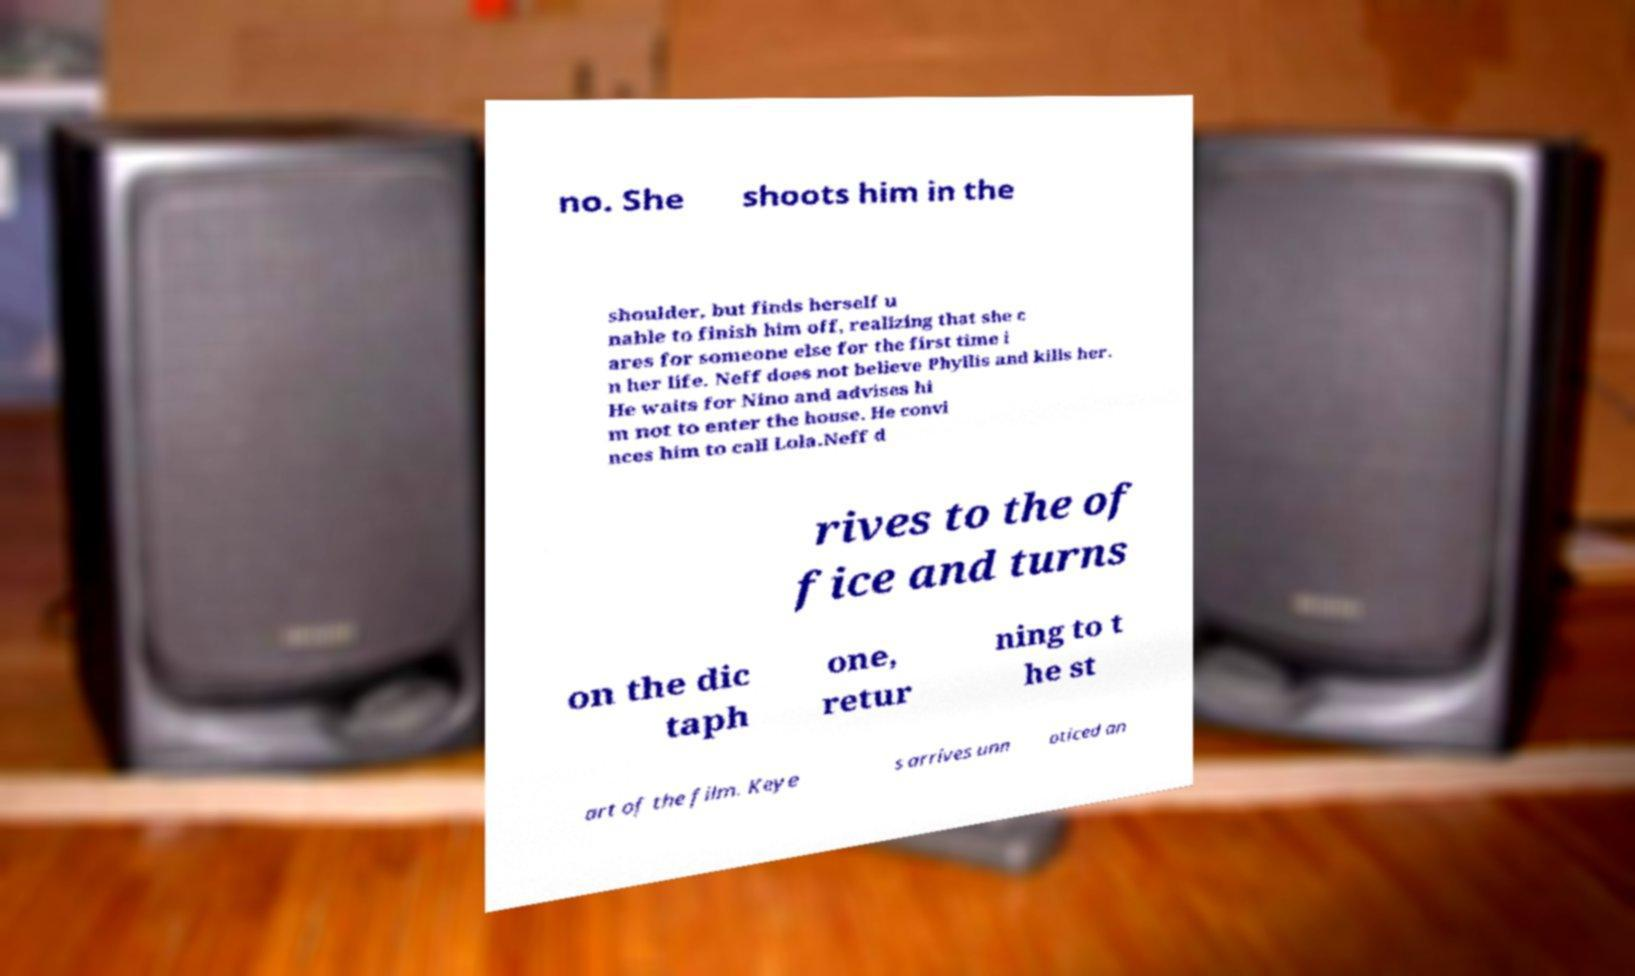Can you accurately transcribe the text from the provided image for me? no. She shoots him in the shoulder, but finds herself u nable to finish him off, realizing that she c ares for someone else for the first time i n her life. Neff does not believe Phyllis and kills her. He waits for Nino and advises hi m not to enter the house. He convi nces him to call Lola.Neff d rives to the of fice and turns on the dic taph one, retur ning to t he st art of the film. Keye s arrives unn oticed an 